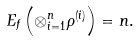<formula> <loc_0><loc_0><loc_500><loc_500>E _ { f } \left ( \otimes _ { i = 1 } ^ { n } \rho ^ { ( i ) } \right ) = n .</formula> 